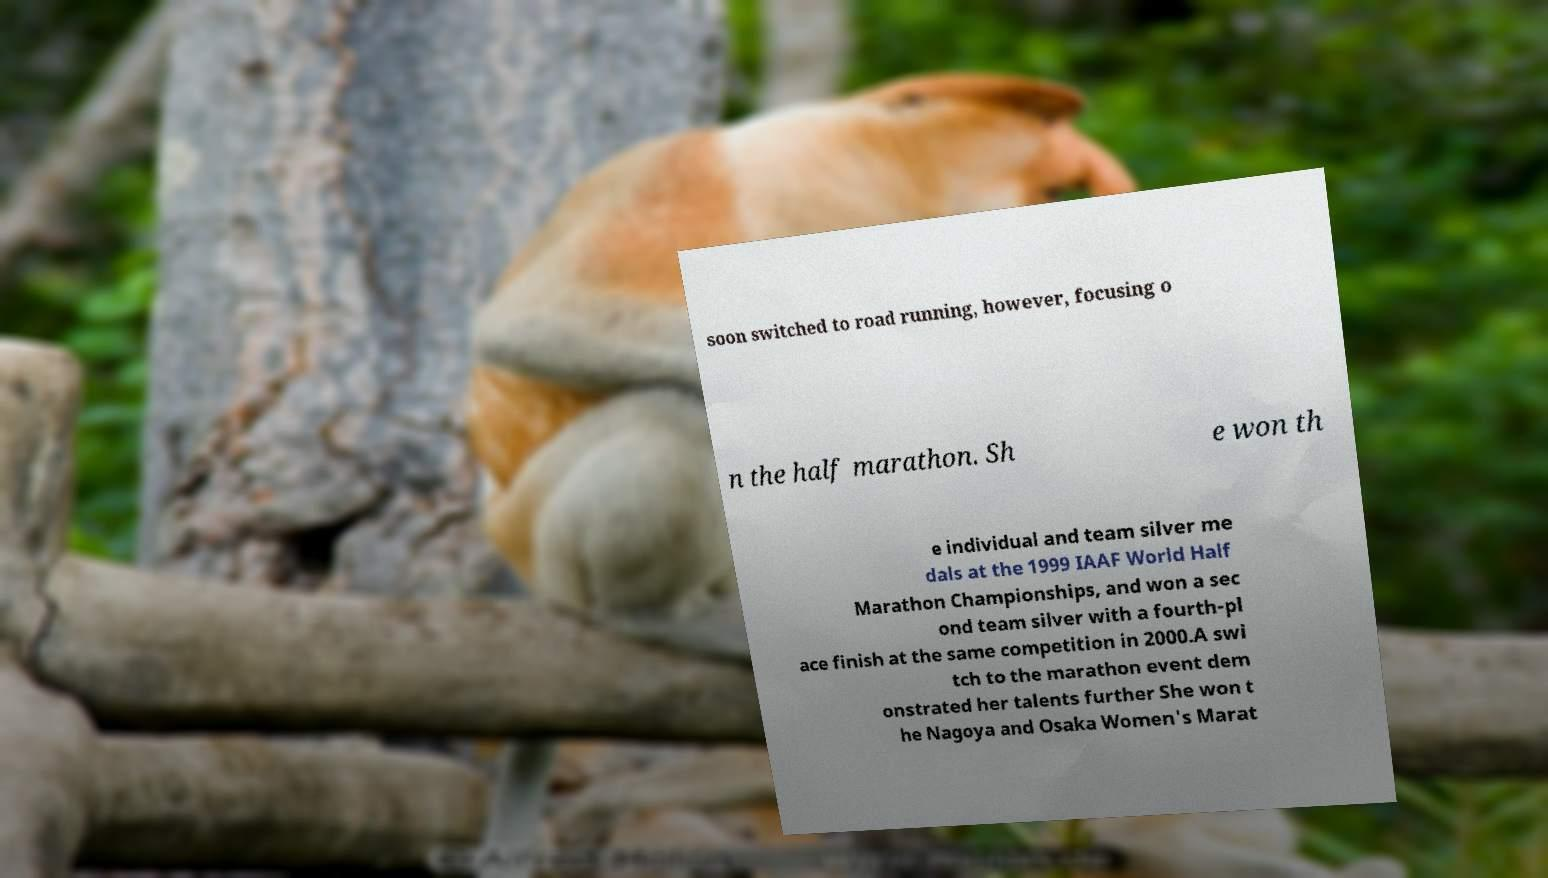There's text embedded in this image that I need extracted. Can you transcribe it verbatim? soon switched to road running, however, focusing o n the half marathon. Sh e won th e individual and team silver me dals at the 1999 IAAF World Half Marathon Championships, and won a sec ond team silver with a fourth-pl ace finish at the same competition in 2000.A swi tch to the marathon event dem onstrated her talents further She won t he Nagoya and Osaka Women's Marat 